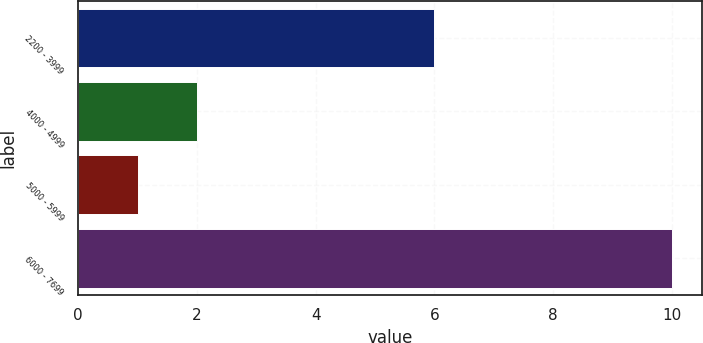Convert chart to OTSL. <chart><loc_0><loc_0><loc_500><loc_500><bar_chart><fcel>2200 - 3999<fcel>4000 - 4999<fcel>5000 - 5999<fcel>6000 - 7699<nl><fcel>6<fcel>2<fcel>1<fcel>10<nl></chart> 